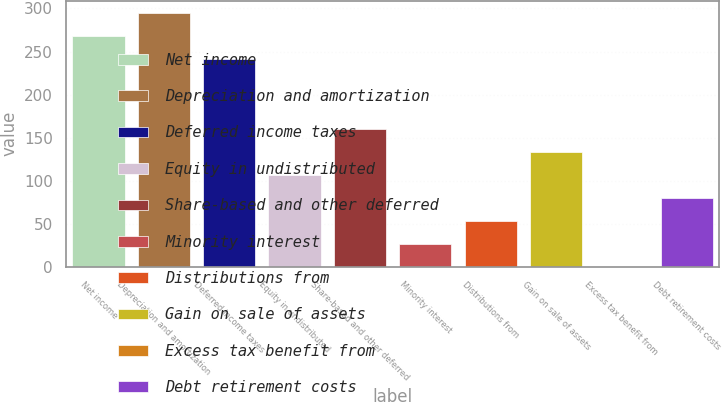<chart> <loc_0><loc_0><loc_500><loc_500><bar_chart><fcel>Net income<fcel>Depreciation and amortization<fcel>Deferred income taxes<fcel>Equity in undistributed<fcel>Share-based and other deferred<fcel>Minority interest<fcel>Distributions from<fcel>Gain on sale of assets<fcel>Excess tax benefit from<fcel>Debt retirement costs<nl><fcel>267.5<fcel>294.23<fcel>240.77<fcel>107.12<fcel>160.58<fcel>26.93<fcel>53.66<fcel>133.85<fcel>0.2<fcel>80.39<nl></chart> 